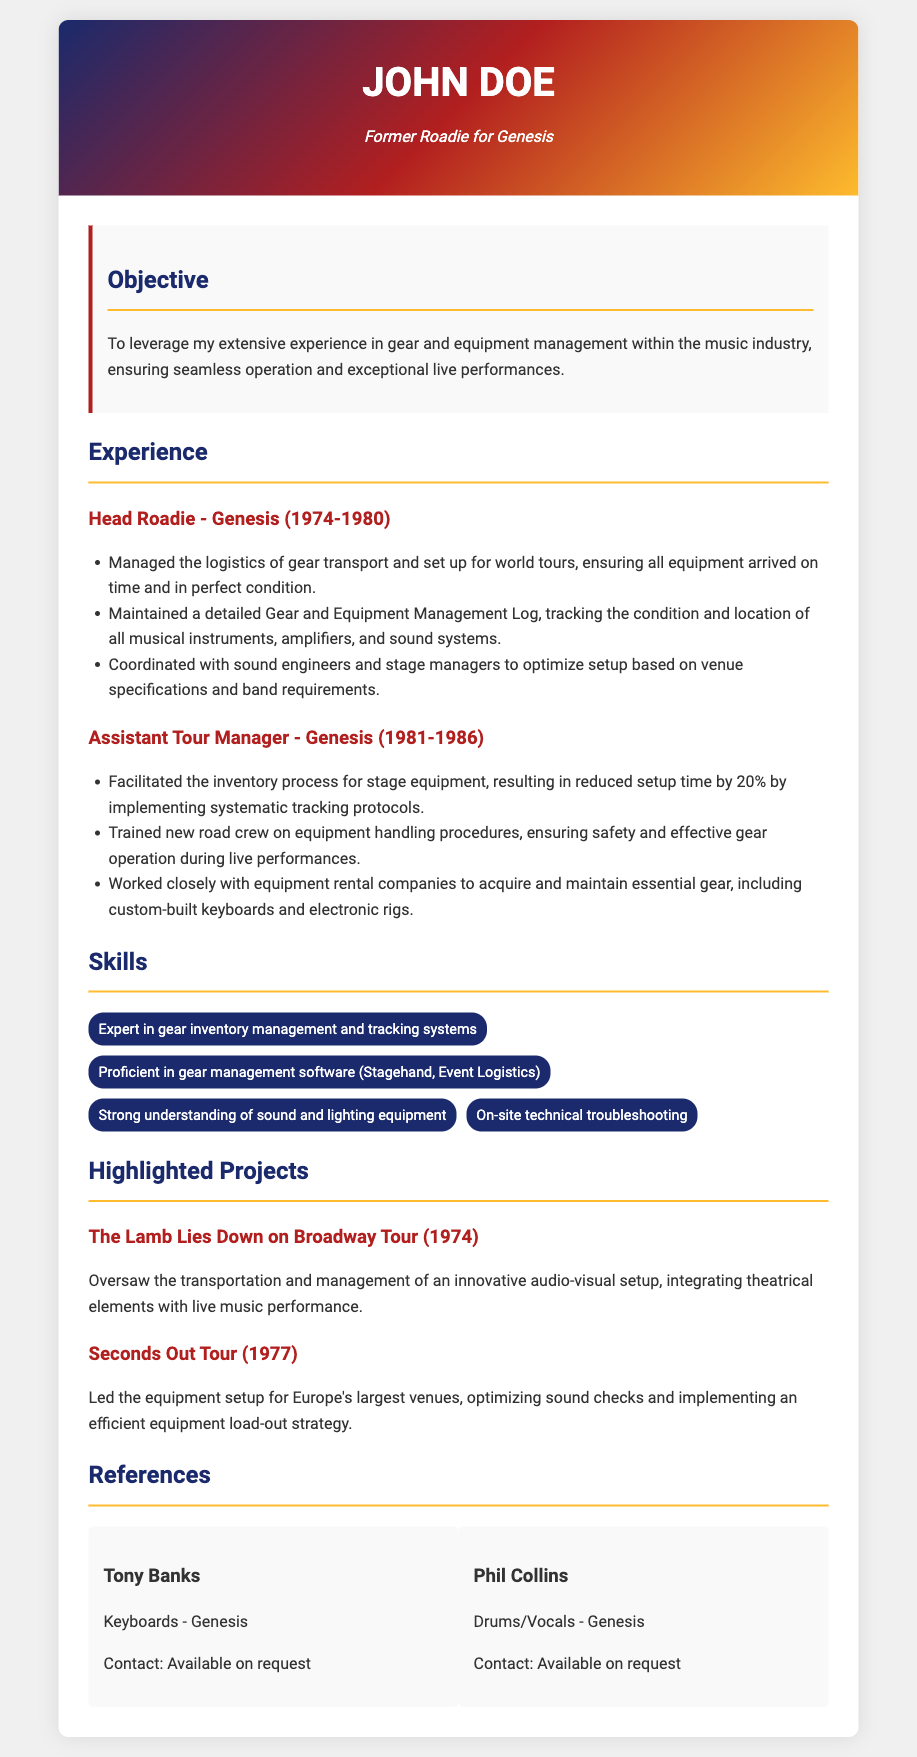what was John Doe’s role in Genesis? The document states that John Doe was the Head Roadie for Genesis from 1974 to 1980.
Answer: Head Roadie what years did John Doe work as an Assistant Tour Manager for Genesis? The document specifies the years John Doe worked as an Assistant Tour Manager for Genesis, which were 1981 to 1986.
Answer: 1981-1986 which tour involved overseeing innovative audio-visual setups? The document describes John Doe's involvement in one project that involved innovative audio-visual setups, specifically during The Lamb Lies Down on Broadway Tour.
Answer: The Lamb Lies Down on Broadway Tour how much did John Doe reduce setup time by implementing systematic tracking protocols? The document mentions that John Doe reduced setup time by 20% through his systematic tracking protocols in equipment inventory.
Answer: 20% name one of the skills listed in the CV. The document lists several skills, one of which is expertise in gear inventory management.
Answer: Expert in gear inventory management what was the main focus of John Doe's objective in the CV? The objective outlined in the document focuses on leveraging experience in gear and equipment management for effective live performances.
Answer: Gear and equipment management who is one reference listed in the CV? The document lists Tony Banks as one reference among others.
Answer: Tony Banks what is the primary responsibility mentioned for John Doe as Head Roadie? The main responsibility mentioned for John Doe as Head Roadie was managing the logistics of gear transport and setup for world tours.
Answer: Managing the logistics of gear transport and setup in which year did The Lamb Lies Down on Broadway Tour take place? The document indicates that The Lamb Lies Down on Broadway Tour took place in 1974.
Answer: 1974 